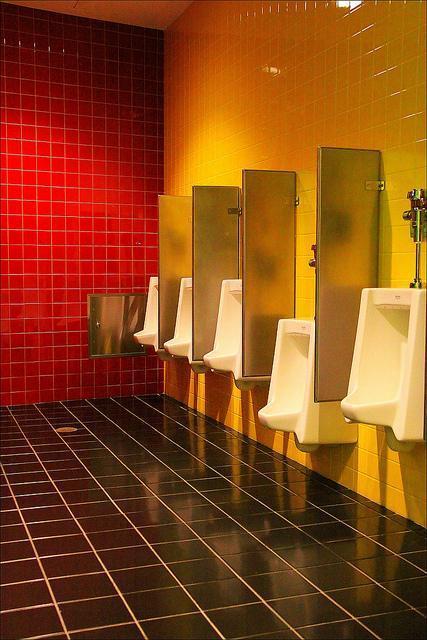How many urinals are there?
Give a very brief answer. 5. How many toilets are visible?
Give a very brief answer. 3. How many freight cars are there?
Give a very brief answer. 0. 